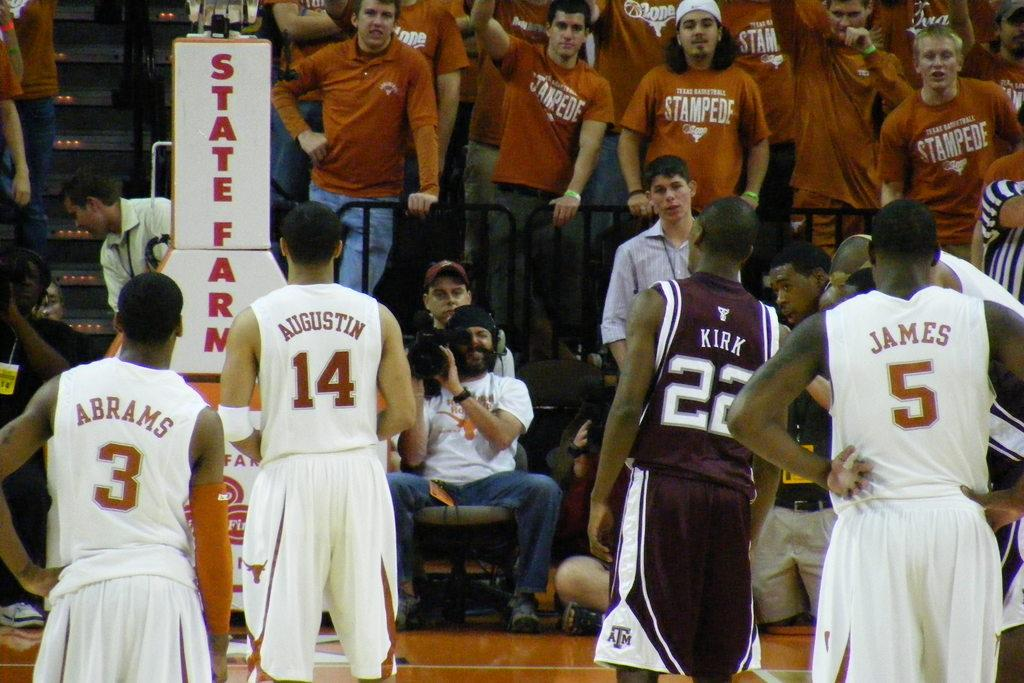<image>
Give a short and clear explanation of the subsequent image. A State Farm ad is near the crowd in the stands 